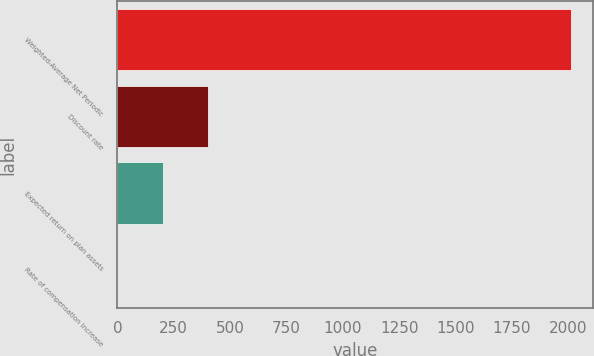<chart> <loc_0><loc_0><loc_500><loc_500><bar_chart><fcel>Weighted-Average Net Periodic<fcel>Discount rate<fcel>Expected return on plan assets<fcel>Rate of compensation increase<nl><fcel>2010<fcel>402.41<fcel>201.46<fcel>0.51<nl></chart> 